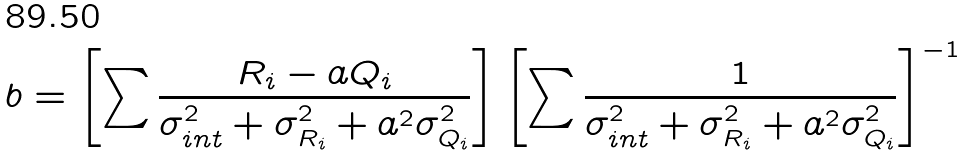<formula> <loc_0><loc_0><loc_500><loc_500>b = \left [ \sum { \frac { R _ { i } - a Q _ { i } } { \sigma _ { i n t } ^ { 2 } + \sigma _ { R _ { i } } ^ { 2 } + a ^ { 2 } \sigma _ { Q _ { i } } ^ { 2 } } } \right ] \left [ \sum { \frac { 1 } { \sigma _ { i n t } ^ { 2 } + \sigma _ { R _ { i } } ^ { 2 } + a ^ { 2 } \sigma _ { Q _ { i } } ^ { 2 } } } \right ] ^ { - 1 }</formula> 